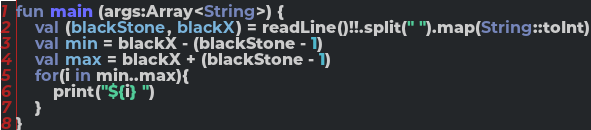Convert code to text. <code><loc_0><loc_0><loc_500><loc_500><_Kotlin_>fun main (args:Array<String>) {
    val (blackStone, blackX) = readLine()!!.split(" ").map(String::toInt)
    val min = blackX - (blackStone - 1)
    val max = blackX + (blackStone - 1)
    for(i in min..max){
        print("${i} ")
    }
}</code> 